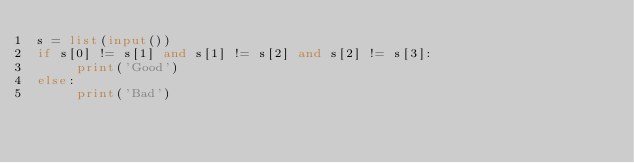<code> <loc_0><loc_0><loc_500><loc_500><_Python_>s = list(input())
if s[0] != s[1] and s[1] != s[2] and s[2] != s[3]:
     print('Good')
else:
     print('Bad')</code> 